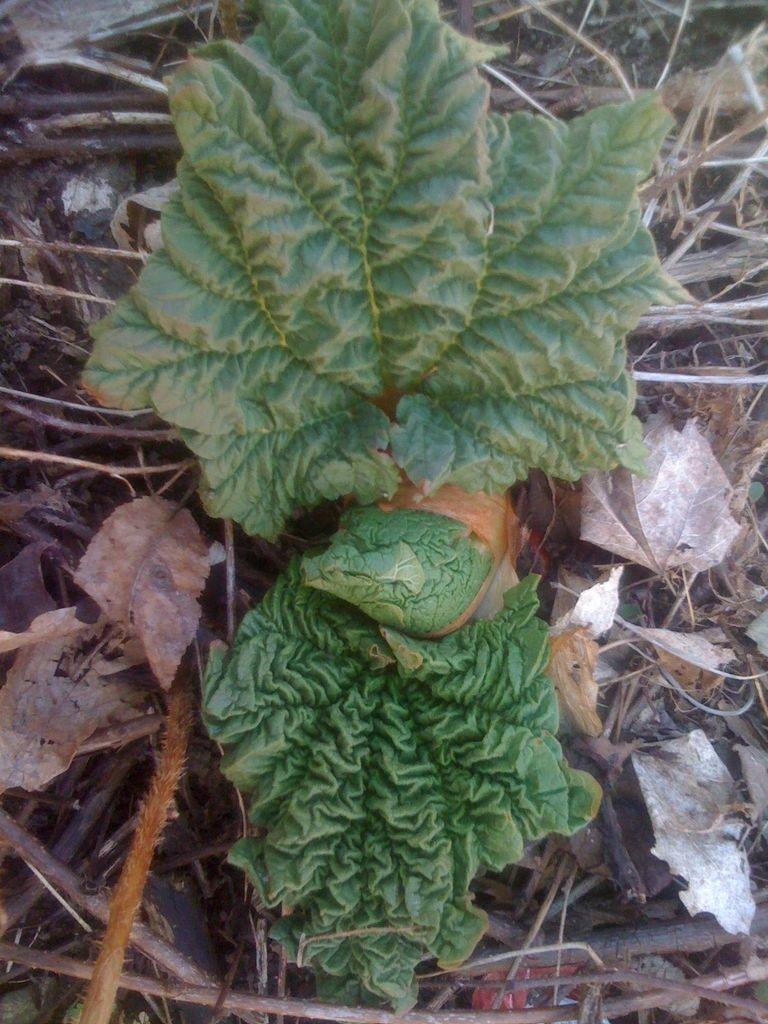Could you give a brief overview of what you see in this image? In this image we can see a plant. Near to that there are dried leaves, sticks and few other things. 